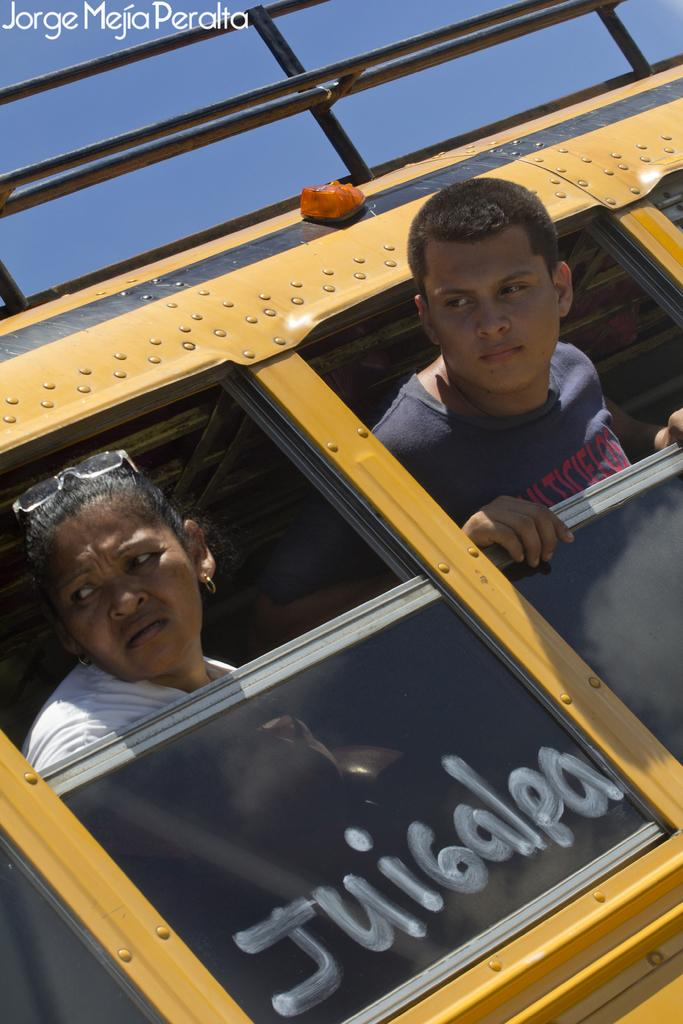How many people are in the image? There are two people in the image. Where are the people located? The people are in a yellow bus. What are the people doing in the image? The people are watching outside the bus. What type of jellyfish can be seen swimming near the bus in the image? There is no jellyfish present in the image; it features two people in a yellow bus. 